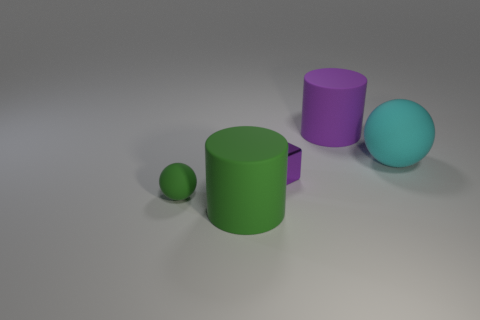Add 1 large matte blocks. How many objects exist? 6 Subtract all purple cylinders. How many cylinders are left? 1 Subtract 0 yellow cubes. How many objects are left? 5 Subtract all blocks. How many objects are left? 4 Subtract 1 cylinders. How many cylinders are left? 1 Subtract all green spheres. Subtract all yellow cylinders. How many spheres are left? 1 Subtract all green matte cylinders. Subtract all cyan balls. How many objects are left? 3 Add 5 big green cylinders. How many big green cylinders are left? 6 Add 5 small shiny cubes. How many small shiny cubes exist? 6 